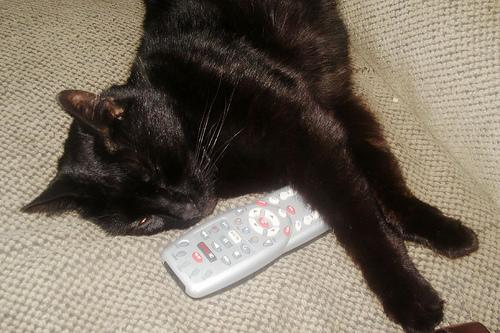Is the cat asleep?
Keep it brief. Yes. Is the cat eating a bird?
Concise answer only. No. What is the cat cuddled up with?
Answer briefly. Remote control. What kind of animal is this?
Keep it brief. Cat. What animal is it?
Answer briefly. Cat. 